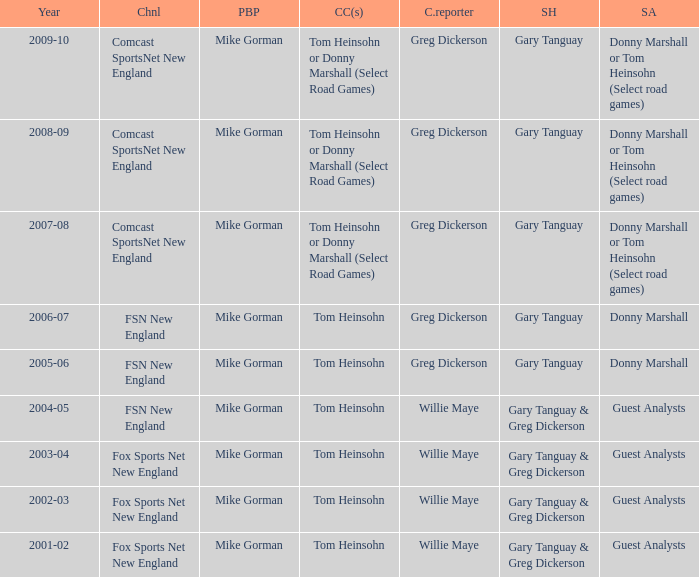Who is the studio host for the year 2006-07? Gary Tanguay. 